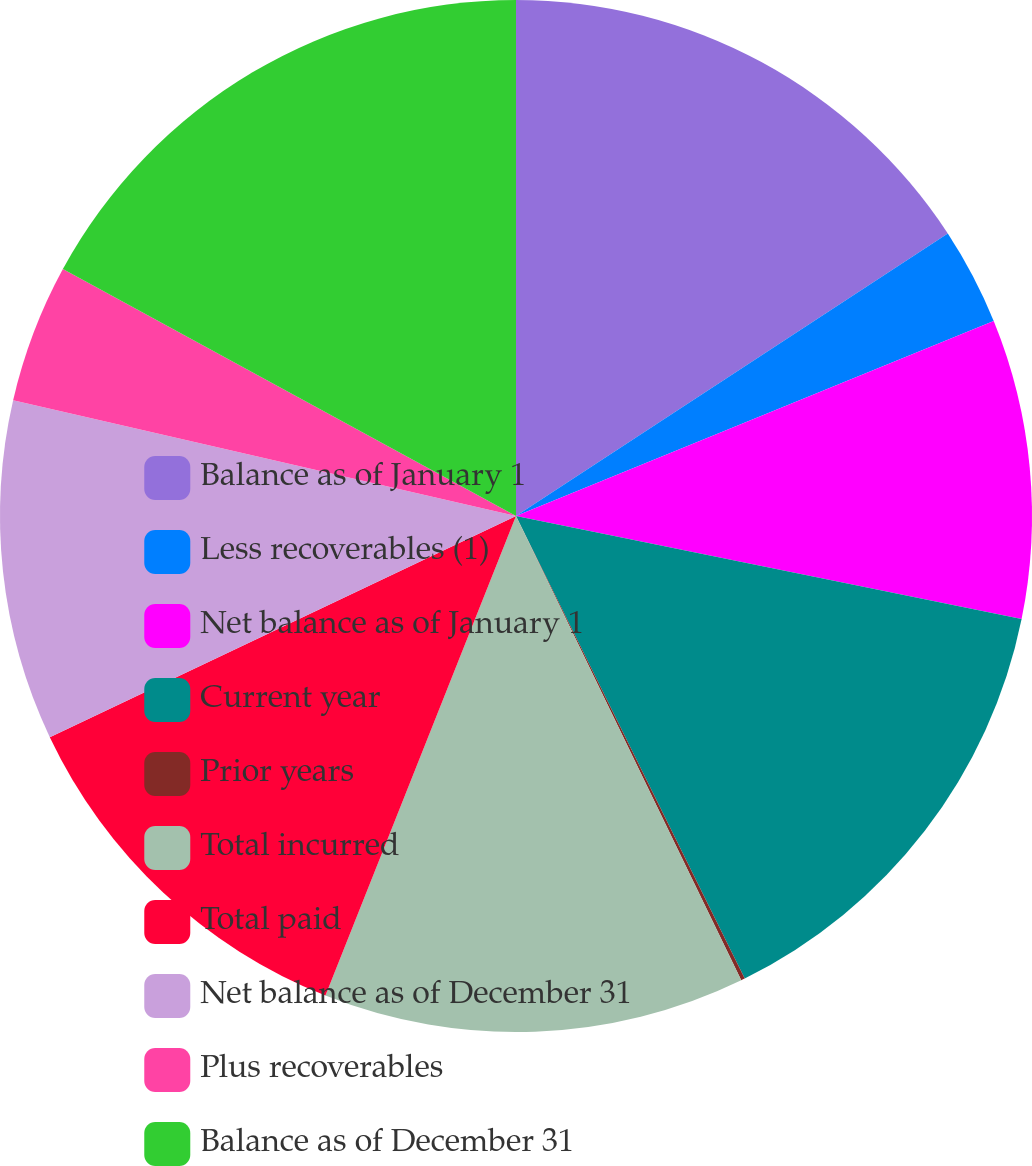Convert chart to OTSL. <chart><loc_0><loc_0><loc_500><loc_500><pie_chart><fcel>Balance as of January 1<fcel>Less recoverables (1)<fcel>Net balance as of January 1<fcel>Current year<fcel>Prior years<fcel>Total incurred<fcel>Total paid<fcel>Net balance as of December 31<fcel>Plus recoverables<fcel>Balance as of December 31<nl><fcel>15.78%<fcel>3.05%<fcel>9.37%<fcel>14.49%<fcel>0.12%<fcel>13.21%<fcel>11.93%<fcel>10.65%<fcel>4.34%<fcel>17.06%<nl></chart> 